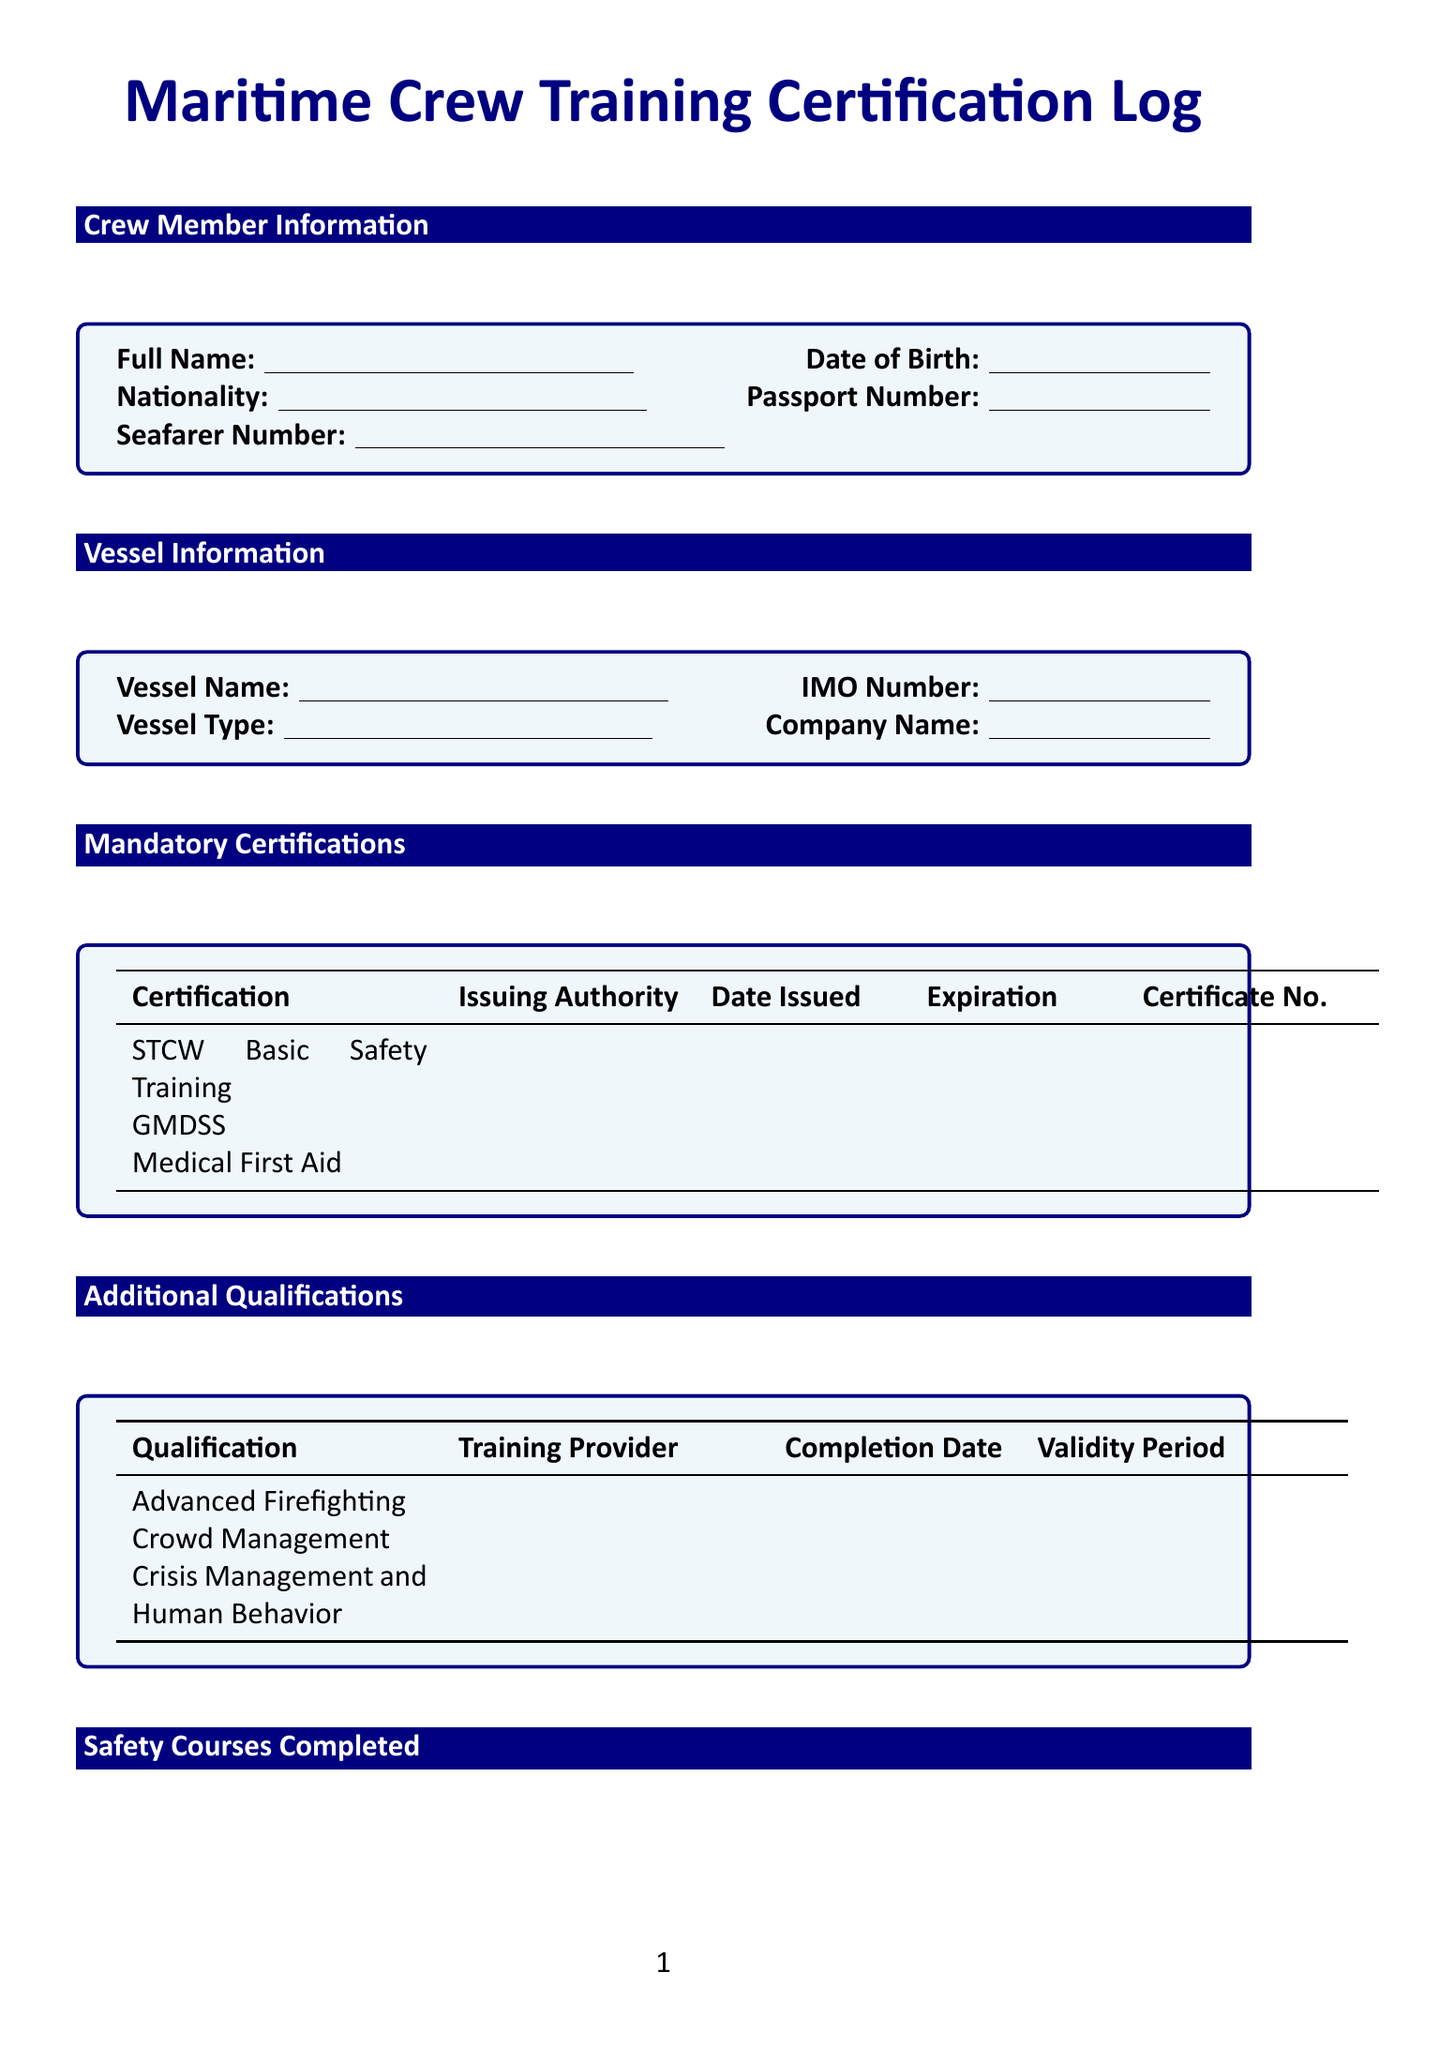What is the full name of the crew member? The crew member's full name is provided in the "Crew Member Information" section.
Answer: string What is the issued date for the STCW Basic Safety Training certification? The issued date is listed under the "Mandatory Certifications" section for the STCW Basic Safety Training.
Answer: date What score did the individual achieve in the Marine Environmental Awareness course? The score achieved is documented under "Safety Courses Completed" for the Marine Environmental Awareness course.
Answer: number Who conducted the Man Overboard Drill? The name of the person or entity that conducted the Man Overboard Drill is found in the "Onboard Safety Drills" section.
Answer: string What is the validity period for the Advanced Firefighting qualification? The validity period is indicated in the "Additional Qualifications" section for the Advanced Firefighting qualification.
Answer: string Which training provider offered the Fatigue Management for Seafarers course? The training provider's name is specified in the "Continuing Education" section for the Fatigue Management for Seafarers course.
Answer: string When was the last verification date? The last verification date is noted in the "Verification and Approval" section.
Answer: date What is the name of the vessel listed in this log? The vessel's name is found in the "Vessel Information" section.
Answer: string 